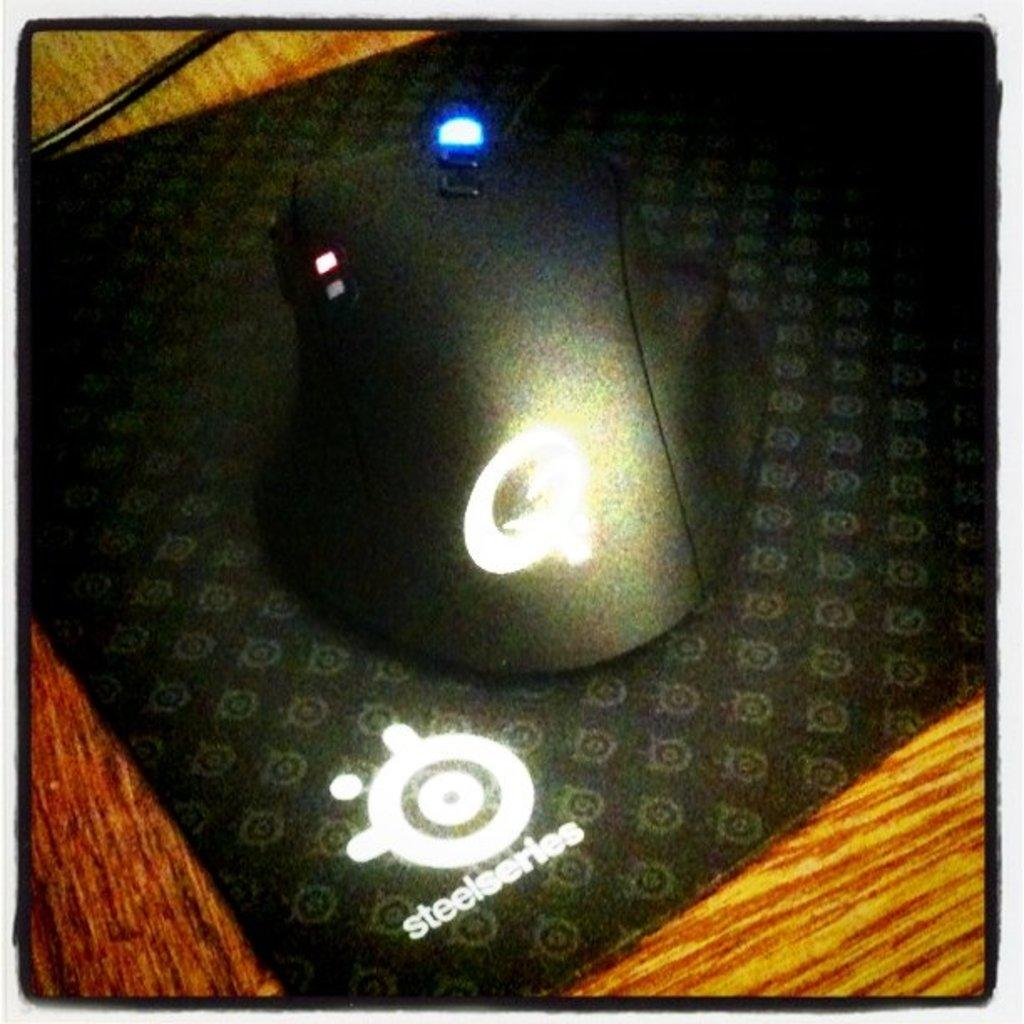<image>
Create a compact narrative representing the image presented. a mouse and a pad with steel series on it 